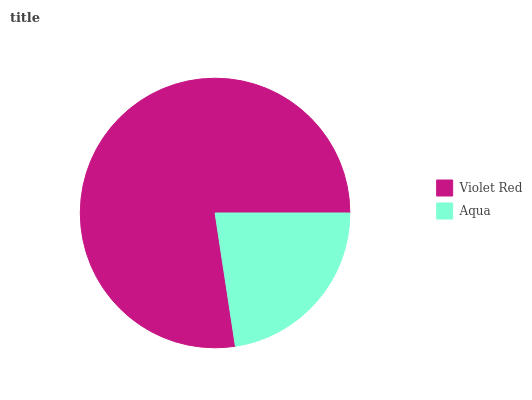Is Aqua the minimum?
Answer yes or no. Yes. Is Violet Red the maximum?
Answer yes or no. Yes. Is Aqua the maximum?
Answer yes or no. No. Is Violet Red greater than Aqua?
Answer yes or no. Yes. Is Aqua less than Violet Red?
Answer yes or no. Yes. Is Aqua greater than Violet Red?
Answer yes or no. No. Is Violet Red less than Aqua?
Answer yes or no. No. Is Violet Red the high median?
Answer yes or no. Yes. Is Aqua the low median?
Answer yes or no. Yes. Is Aqua the high median?
Answer yes or no. No. Is Violet Red the low median?
Answer yes or no. No. 